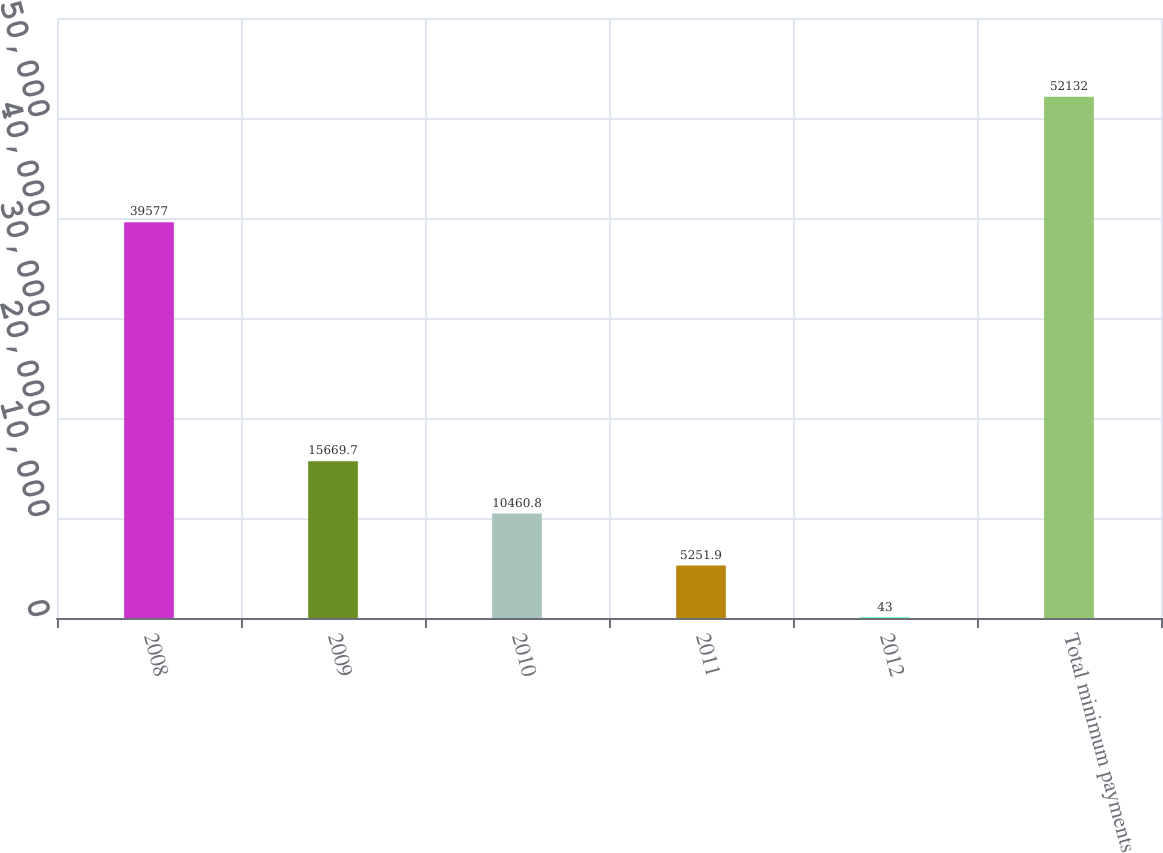<chart> <loc_0><loc_0><loc_500><loc_500><bar_chart><fcel>2008<fcel>2009<fcel>2010<fcel>2011<fcel>2012<fcel>Total minimum payments<nl><fcel>39577<fcel>15669.7<fcel>10460.8<fcel>5251.9<fcel>43<fcel>52132<nl></chart> 